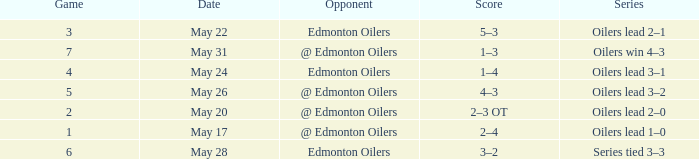Sequence of oilers triumph 4-3 had which topmost match? 7.0. 